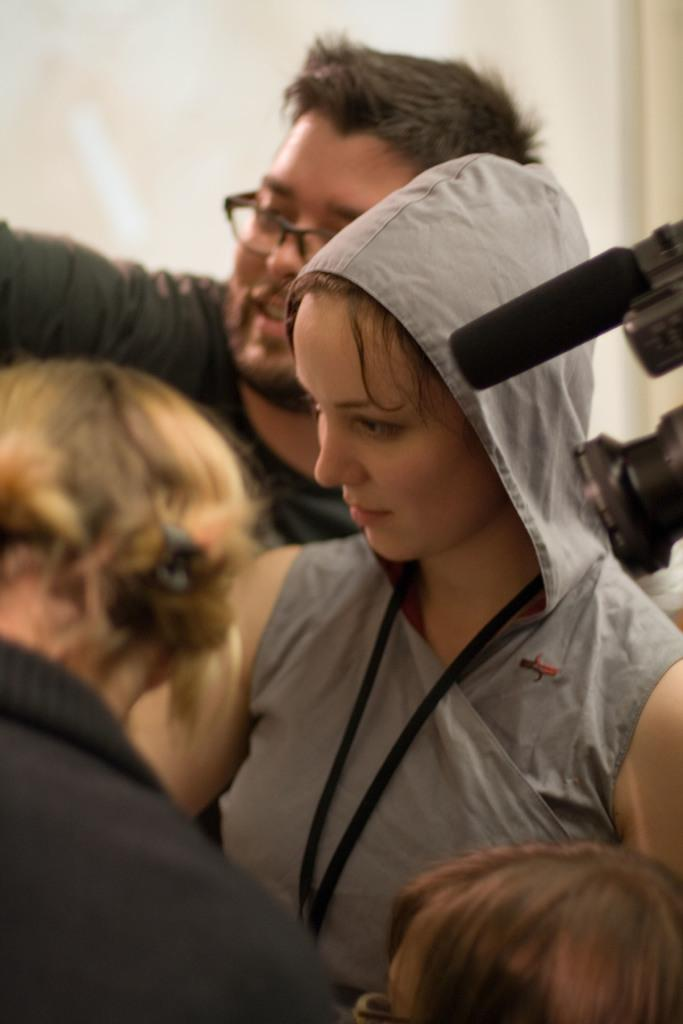How many people are in the image? There is a group of people in the image. What are the people doing in the image? The people are standing. What can be seen on the right side of the people? There is a camera with a microphone on the right side of the people. What is behind the people in the image? There is a wall behind the people. What statement does the person in the middle of the group make in the image? There is no statement made by any person in the image; we can only observe their actions and the presence of a camera with a microphone. 